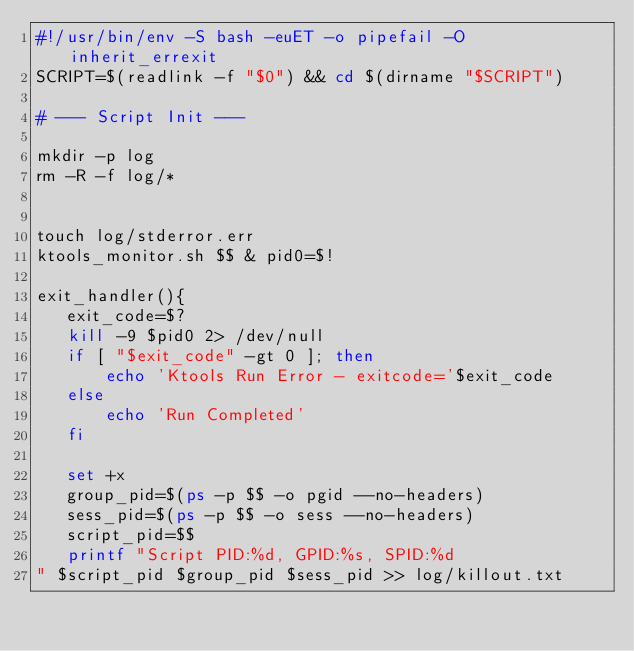Convert code to text. <code><loc_0><loc_0><loc_500><loc_500><_Bash_>#!/usr/bin/env -S bash -euET -o pipefail -O inherit_errexit
SCRIPT=$(readlink -f "$0") && cd $(dirname "$SCRIPT")

# --- Script Init ---

mkdir -p log
rm -R -f log/*


touch log/stderror.err
ktools_monitor.sh $$ & pid0=$!

exit_handler(){
   exit_code=$?
   kill -9 $pid0 2> /dev/null
   if [ "$exit_code" -gt 0 ]; then
       echo 'Ktools Run Error - exitcode='$exit_code
   else
       echo 'Run Completed'
   fi

   set +x
   group_pid=$(ps -p $$ -o pgid --no-headers)
   sess_pid=$(ps -p $$ -o sess --no-headers)
   script_pid=$$
   printf "Script PID:%d, GPID:%s, SPID:%d
" $script_pid $group_pid $sess_pid >> log/killout.txt
</code> 